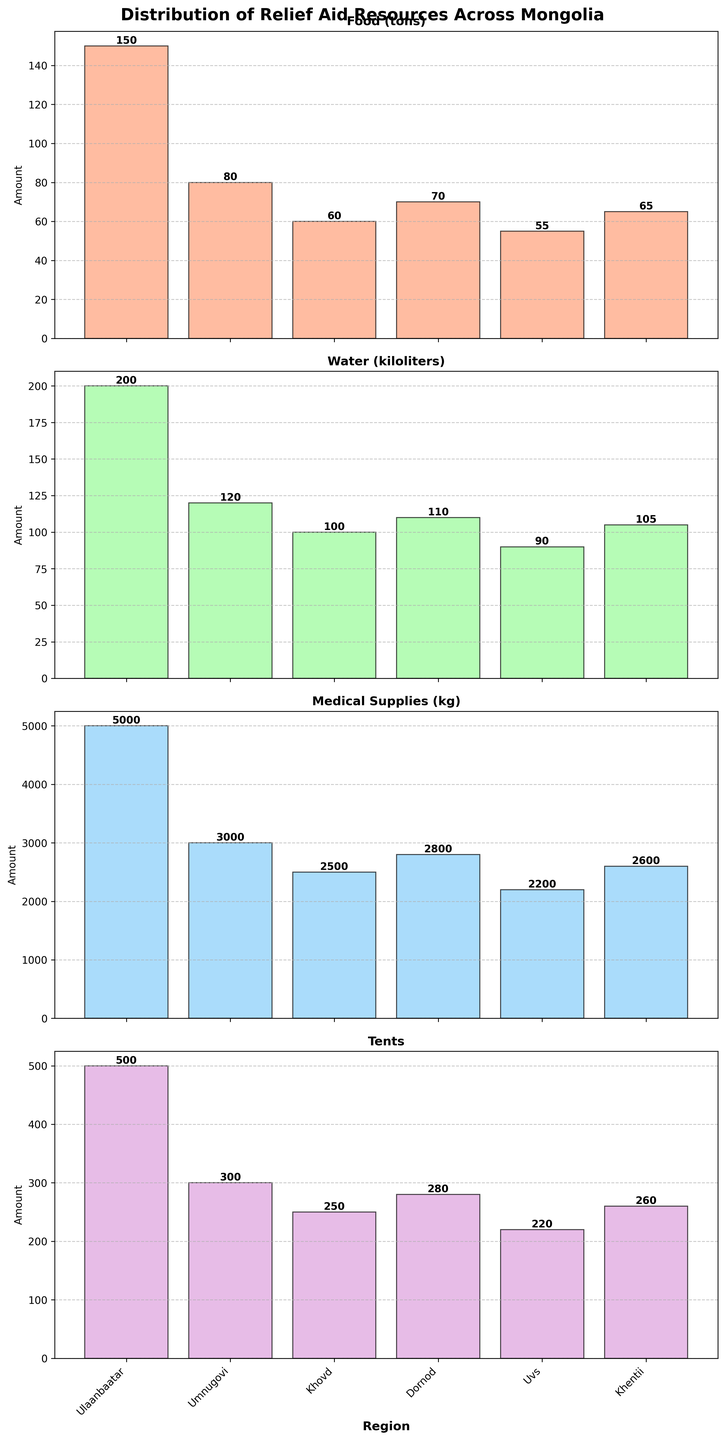what is the total amount of food distributed across all regions? To find the total amount of food distributed, we sum the food quantities for all regions: 150 (Ulaanbaatar) + 80 (Umnugovi) + 60 (Khovd) + 70 (Dornod) + 55 (Uvs) + 65 (Khentii) = 480 tons.
Answer: 480 tons Which region received the most water? By comparing the water values for each region, Ulaanbaatar received the highest amount, with 200 kiloliters of water.
Answer: Ulaanbaatar What are the regions with the least amount of tents distributed? By looking at the tents data, Uvs received the least amount, with 220 tents.
Answer: Uvs What is the difference in the amount of medical supplies between Ulaanbaatar and Umnugovi? Ulaanbaatar received 5000 kg of medical supplies, while Umnugovi received 3000 kg. The difference is 5000 - 3000 = 2000 kg.
Answer: 2000 kg Which region received more food: Khovd or Dornod? Comparing the food quantities, Khovd received 60 tons, and Dornod received 70 tons. Dornod received more food.
Answer: Dornod What is the average amount of water distributed across all regions? Sum the water quantities for all regions: 200 + 120 + 100 + 110 + 90 + 105 = 725 kiloliters. There are 6 regions, so the average is 725 / 6 = 120.83 kiloliters.
Answer: 120.83 kiloliters Which two regions have an equal amount of tents distributed? By comparing the tents data, Umnugovi and Khovd both received 300 tents.
Answer: Umnugovi and Khovd What is the total number of tents distributed across all regions? Sum the tents quantities for all regions: 500 (Ulaanbaatar) + 300 (Umnugovi) + 250 (Khovd) + 280 (Dornod) + 220 (Uvs) + 260 (Khentii) = 1810 tents.
Answer: 1810 tents Which category shows the largest variation among regions? By examining the four subplots, the medical supplies category (ranging from 2200 to 5000 kg) shows the largest variation.
Answer: Medical Supplies What is the total amount of medical supplies distributed in Uvs and Khentii combined? Uvs received 2200 kg and Khentii received 2600 kg. Their combined total is 2200 + 2600 = 4800 kg.
Answer: 4800 kg 